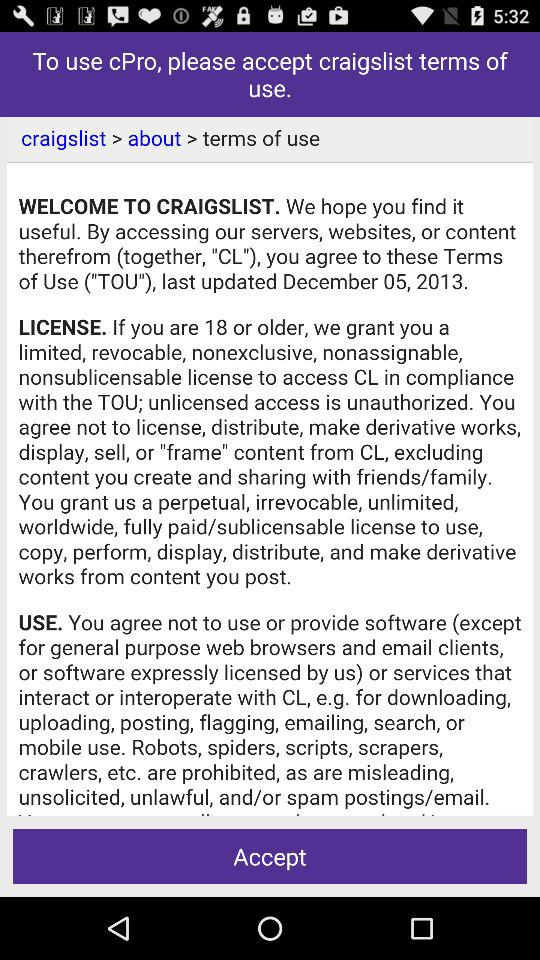What is the minimum age to get a license to access CL in compliance with the TOU? The minimum age to get a license to access CL in compliance with the TOU is 18 years. 